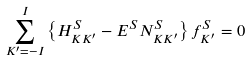<formula> <loc_0><loc_0><loc_500><loc_500>\sum _ { K ^ { \prime } = - I } ^ { I } \left \{ H _ { K K ^ { \prime } } ^ { S } - E ^ { S } N _ { K K ^ { \prime } } ^ { S } \right \} f _ { K ^ { \prime } } ^ { S } = 0</formula> 